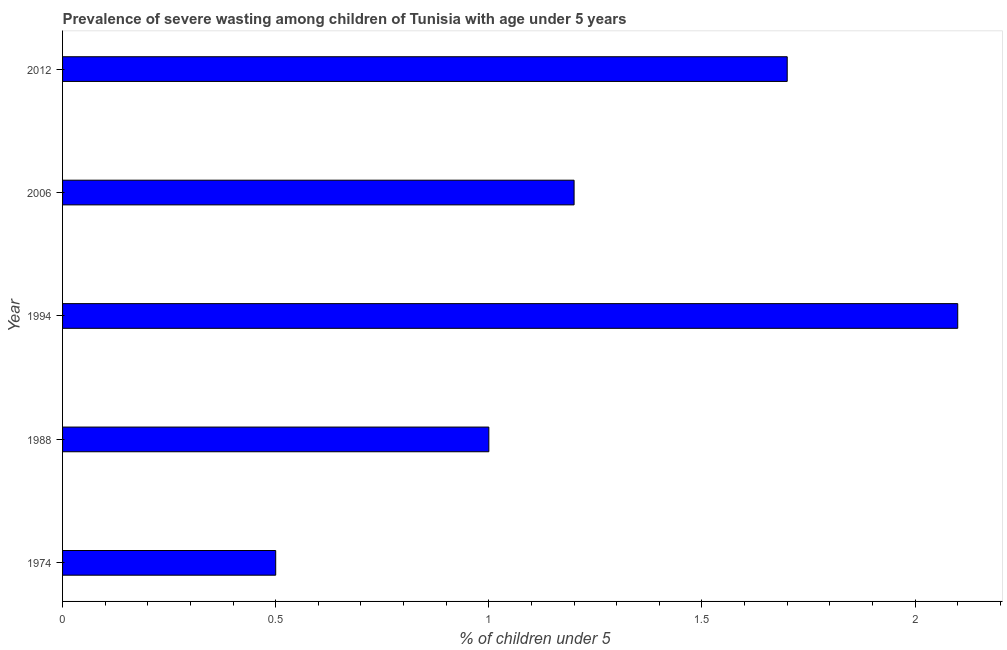Does the graph contain any zero values?
Your answer should be compact. No. Does the graph contain grids?
Give a very brief answer. No. What is the title of the graph?
Your response must be concise. Prevalence of severe wasting among children of Tunisia with age under 5 years. What is the label or title of the X-axis?
Your answer should be compact.  % of children under 5. What is the label or title of the Y-axis?
Make the answer very short. Year. What is the prevalence of severe wasting in 2006?
Give a very brief answer. 1.2. Across all years, what is the maximum prevalence of severe wasting?
Offer a terse response. 2.1. Across all years, what is the minimum prevalence of severe wasting?
Make the answer very short. 0.5. In which year was the prevalence of severe wasting minimum?
Offer a terse response. 1974. What is the sum of the prevalence of severe wasting?
Make the answer very short. 6.5. What is the difference between the prevalence of severe wasting in 1974 and 2006?
Provide a short and direct response. -0.7. What is the median prevalence of severe wasting?
Ensure brevity in your answer.  1.2. In how many years, is the prevalence of severe wasting greater than 2 %?
Offer a very short reply. 1. What is the ratio of the prevalence of severe wasting in 1974 to that in 2012?
Your answer should be very brief. 0.29. What is the difference between the highest and the second highest prevalence of severe wasting?
Offer a very short reply. 0.4. Is the sum of the prevalence of severe wasting in 2006 and 2012 greater than the maximum prevalence of severe wasting across all years?
Give a very brief answer. Yes. What is the difference between the highest and the lowest prevalence of severe wasting?
Give a very brief answer. 1.6. What is the difference between two consecutive major ticks on the X-axis?
Your response must be concise. 0.5. Are the values on the major ticks of X-axis written in scientific E-notation?
Provide a short and direct response. No. What is the  % of children under 5 of 1988?
Provide a short and direct response. 1. What is the  % of children under 5 in 1994?
Your answer should be very brief. 2.1. What is the  % of children under 5 of 2006?
Your answer should be very brief. 1.2. What is the  % of children under 5 in 2012?
Ensure brevity in your answer.  1.7. What is the difference between the  % of children under 5 in 1974 and 2006?
Offer a very short reply. -0.7. What is the difference between the  % of children under 5 in 1988 and 1994?
Make the answer very short. -1.1. What is the difference between the  % of children under 5 in 1994 and 2006?
Ensure brevity in your answer.  0.9. What is the difference between the  % of children under 5 in 1994 and 2012?
Keep it short and to the point. 0.4. What is the ratio of the  % of children under 5 in 1974 to that in 1994?
Give a very brief answer. 0.24. What is the ratio of the  % of children under 5 in 1974 to that in 2006?
Your response must be concise. 0.42. What is the ratio of the  % of children under 5 in 1974 to that in 2012?
Offer a very short reply. 0.29. What is the ratio of the  % of children under 5 in 1988 to that in 1994?
Ensure brevity in your answer.  0.48. What is the ratio of the  % of children under 5 in 1988 to that in 2006?
Your response must be concise. 0.83. What is the ratio of the  % of children under 5 in 1988 to that in 2012?
Provide a succinct answer. 0.59. What is the ratio of the  % of children under 5 in 1994 to that in 2006?
Keep it short and to the point. 1.75. What is the ratio of the  % of children under 5 in 1994 to that in 2012?
Give a very brief answer. 1.24. What is the ratio of the  % of children under 5 in 2006 to that in 2012?
Provide a succinct answer. 0.71. 